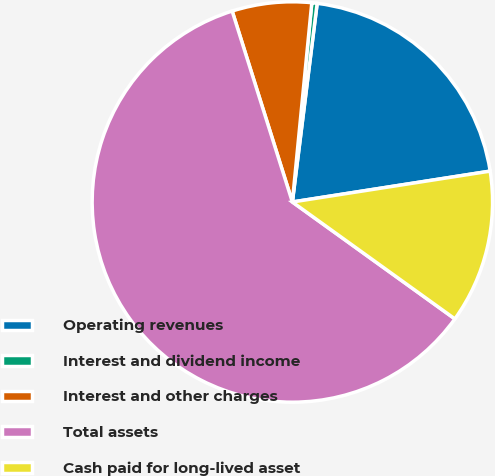Convert chart. <chart><loc_0><loc_0><loc_500><loc_500><pie_chart><fcel>Operating revenues<fcel>Interest and dividend income<fcel>Interest and other charges<fcel>Total assets<fcel>Cash paid for long-lived asset<nl><fcel>20.56%<fcel>0.43%<fcel>6.41%<fcel>60.22%<fcel>12.39%<nl></chart> 